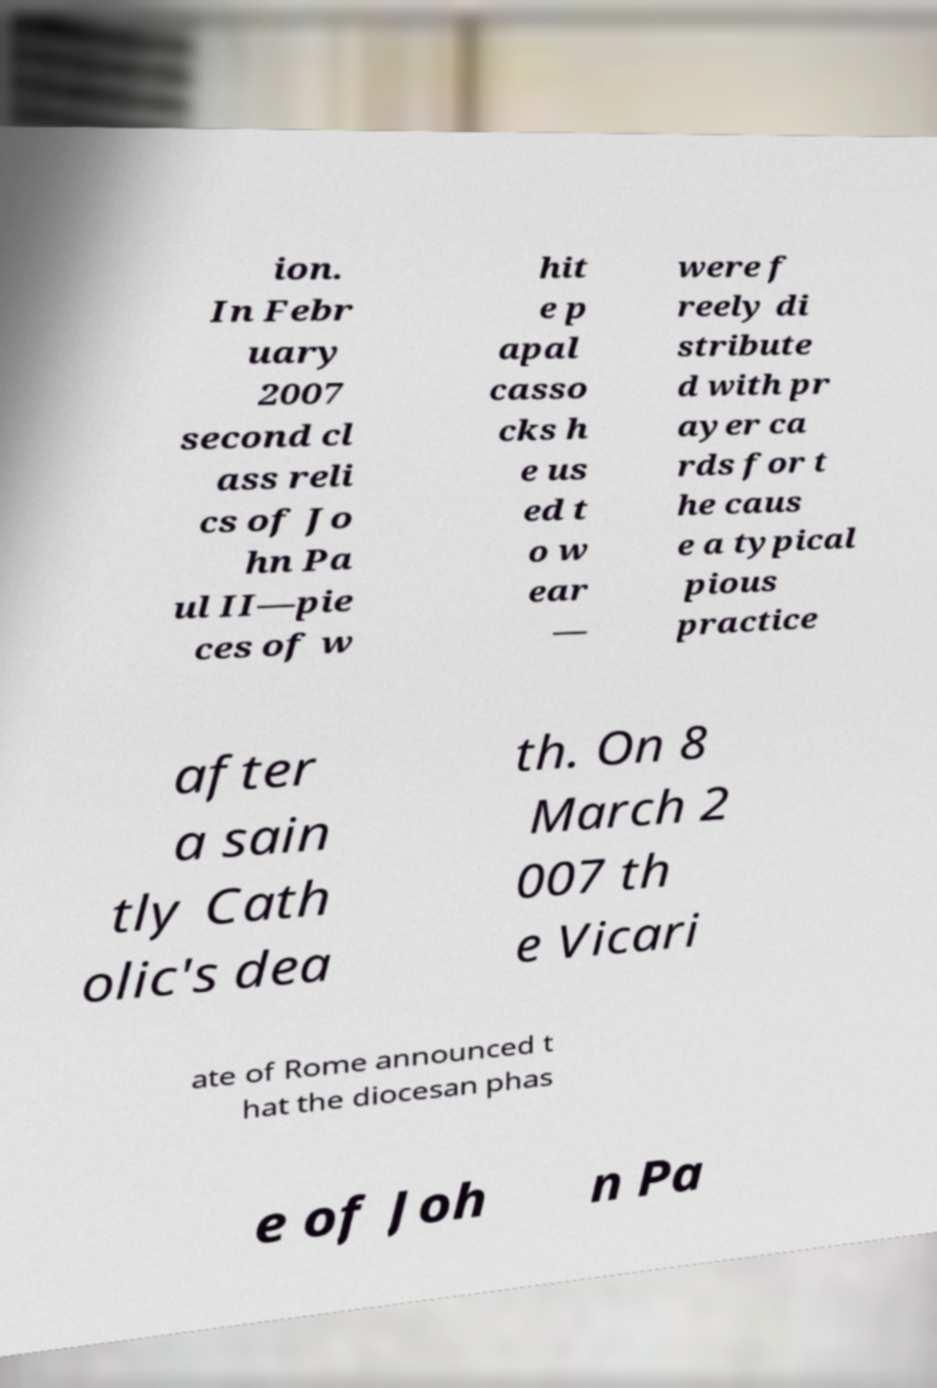Please identify and transcribe the text found in this image. ion. In Febr uary 2007 second cl ass reli cs of Jo hn Pa ul II—pie ces of w hit e p apal casso cks h e us ed t o w ear — were f reely di stribute d with pr ayer ca rds for t he caus e a typical pious practice after a sain tly Cath olic's dea th. On 8 March 2 007 th e Vicari ate of Rome announced t hat the diocesan phas e of Joh n Pa 